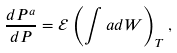Convert formula to latex. <formula><loc_0><loc_0><loc_500><loc_500>\frac { d P ^ { a } } { d P } = \mathcal { E } \left ( \int a d W \right ) _ { T } ,</formula> 